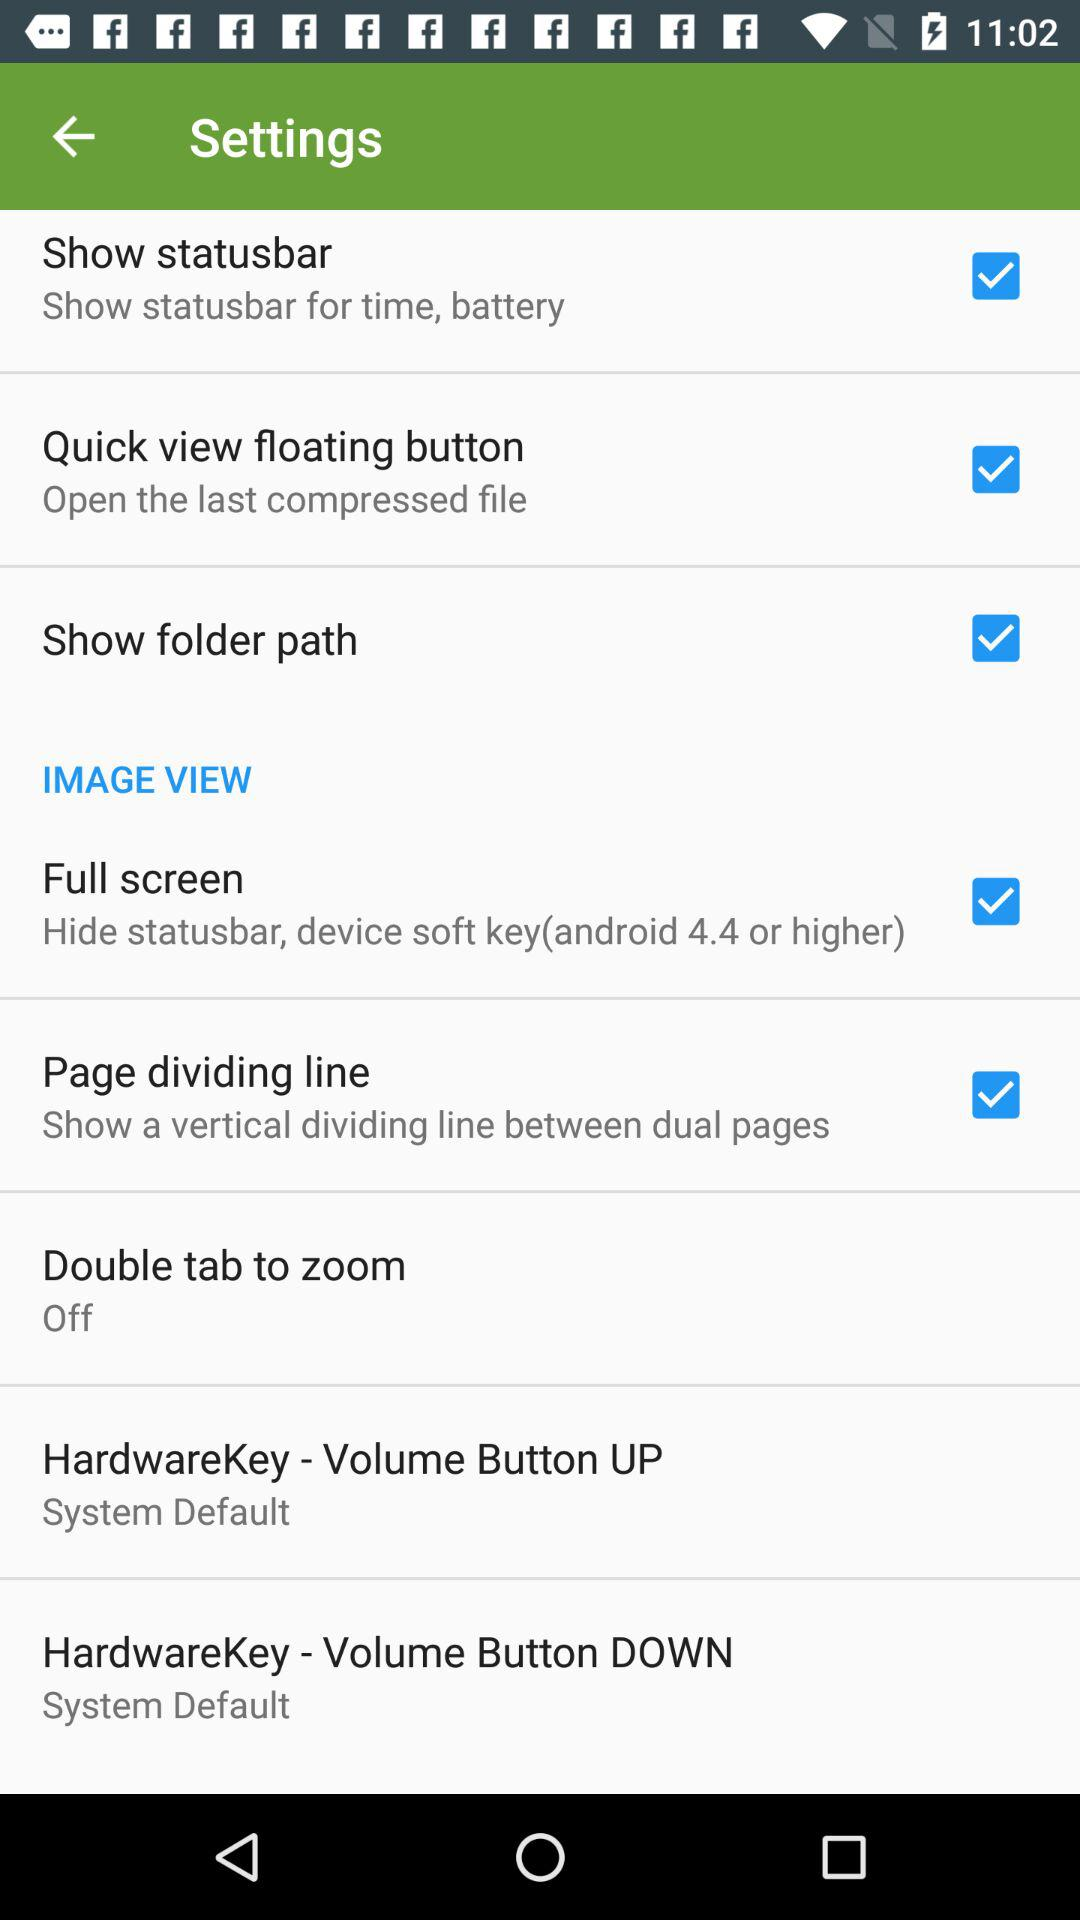What is the setting for the "Full screen"? The setting is "Hide statusbar, device soft key(android 4.4 or higher)". 